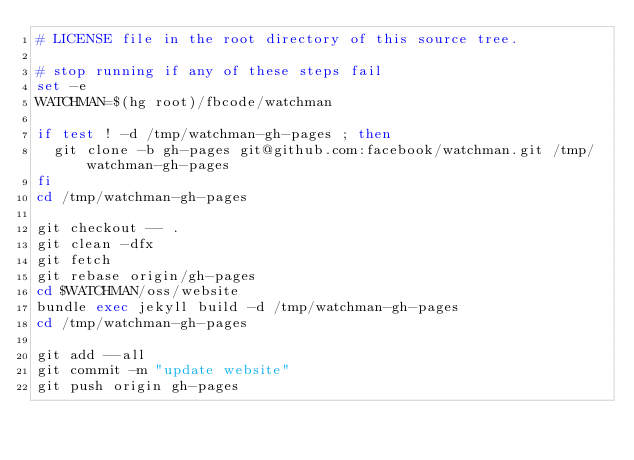<code> <loc_0><loc_0><loc_500><loc_500><_Bash_># LICENSE file in the root directory of this source tree.

# stop running if any of these steps fail
set -e
WATCHMAN=$(hg root)/fbcode/watchman

if test ! -d /tmp/watchman-gh-pages ; then
  git clone -b gh-pages git@github.com:facebook/watchman.git /tmp/watchman-gh-pages
fi
cd /tmp/watchman-gh-pages

git checkout -- .
git clean -dfx
git fetch
git rebase origin/gh-pages
cd $WATCHMAN/oss/website
bundle exec jekyll build -d /tmp/watchman-gh-pages
cd /tmp/watchman-gh-pages

git add --all
git commit -m "update website"
git push origin gh-pages
</code> 